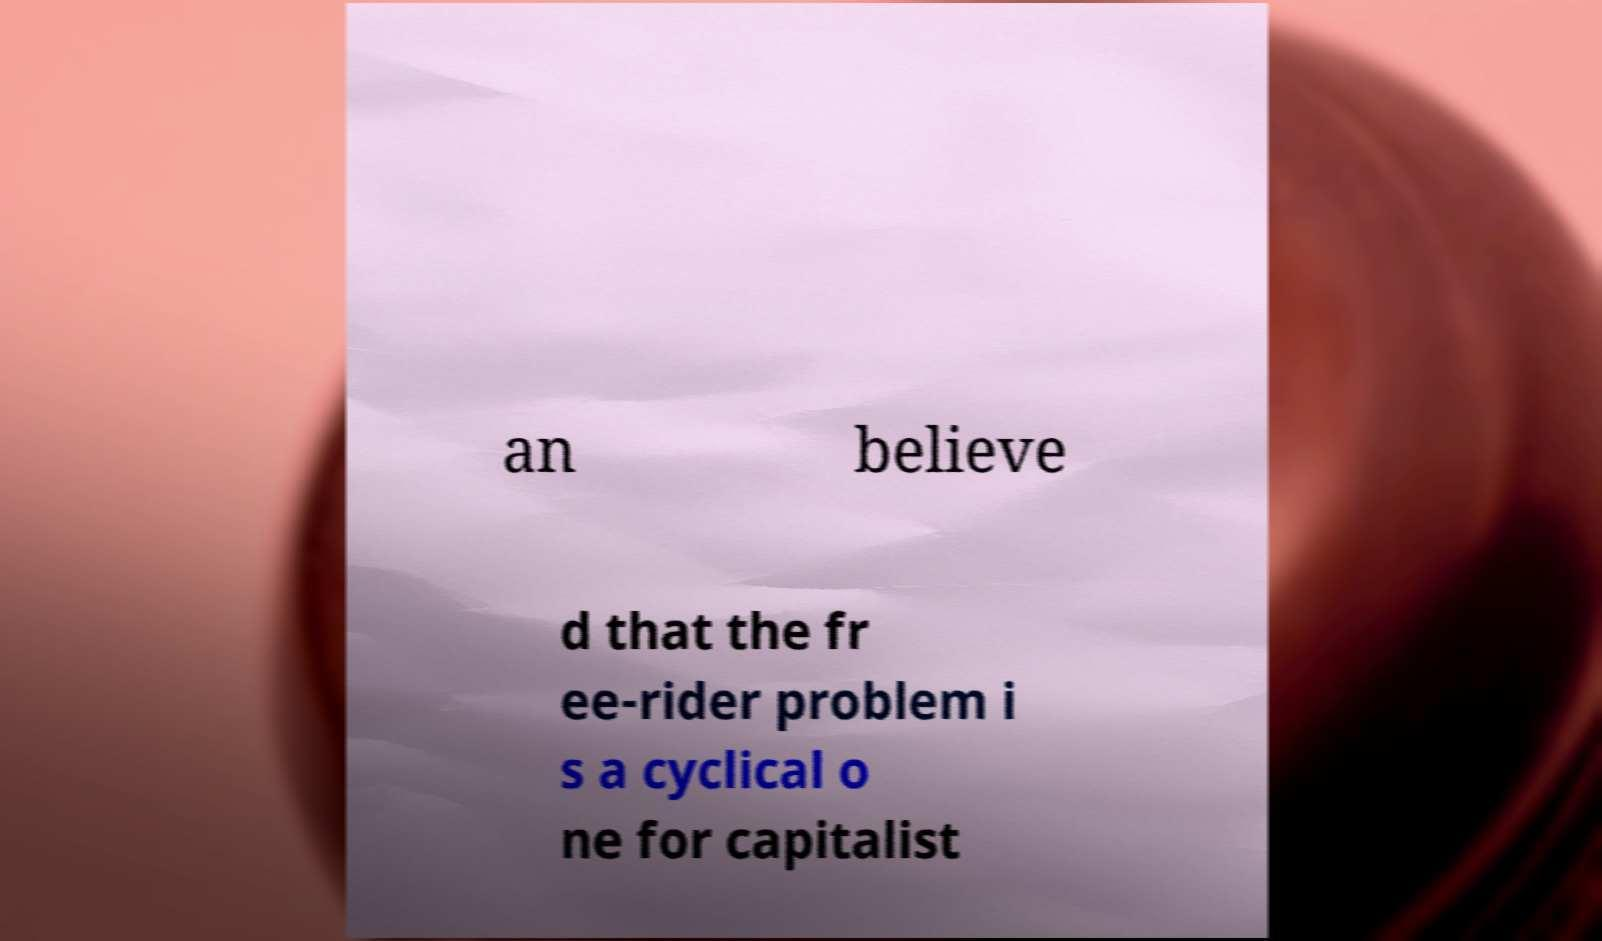Could you extract and type out the text from this image? an believe d that the fr ee-rider problem i s a cyclical o ne for capitalist 